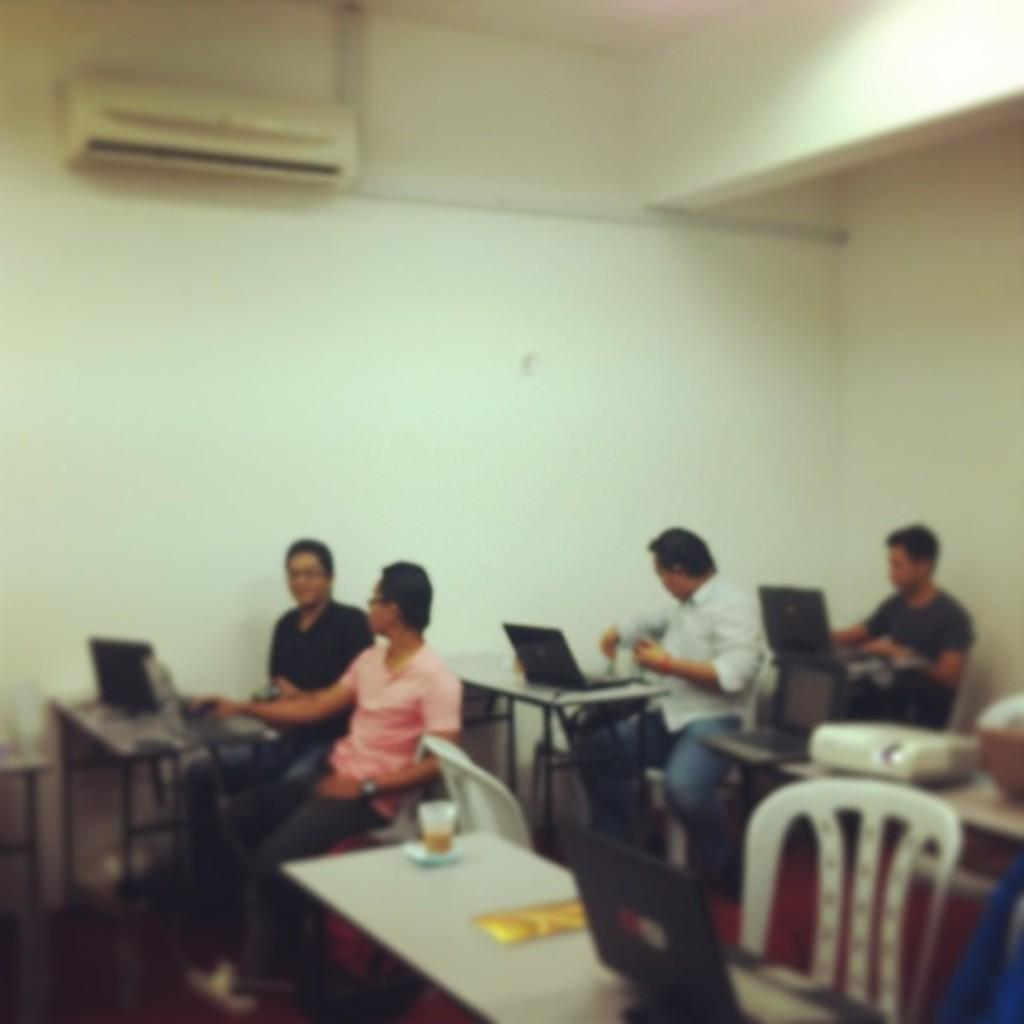How many people are in the image? There is a group of persons in the image. Where are the persons located in the image? The persons are sitting in a room. What are the persons sitting on? The persons are sitting on chairs. What activity are the persons engaged in? The persons are doing some work. What is present on the wall in the image? There is an A.C. attached to the wall in the image. What type of suit is the sister wearing in the image? There is no sister or suit present in the image. What emotion can be seen on the faces of the persons in the image? The provided facts do not mention any emotions or facial expressions of the persons in the image. 